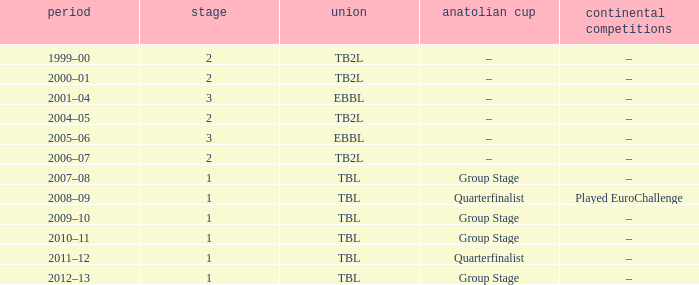Tier of 2, and a Season of 2004–05 is what European competitions? –. 